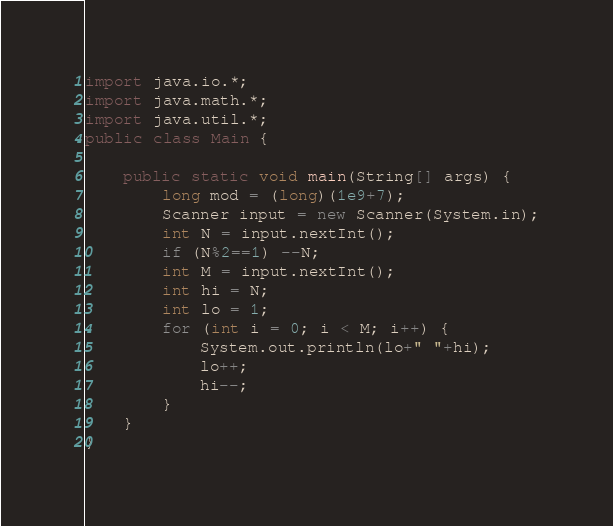Convert code to text. <code><loc_0><loc_0><loc_500><loc_500><_Java_>import java.io.*;
import java.math.*;
import java.util.*;
public class Main {

	public static void main(String[] args) {
		long mod = (long)(1e9+7);
		Scanner input = new Scanner(System.in);
		int N = input.nextInt();
		if (N%2==1) --N;
		int M = input.nextInt();
		int hi = N;
		int lo = 1;
		for (int i = 0; i < M; i++) {
			System.out.println(lo+" "+hi);
			lo++;
			hi--;
		}
	}
}</code> 